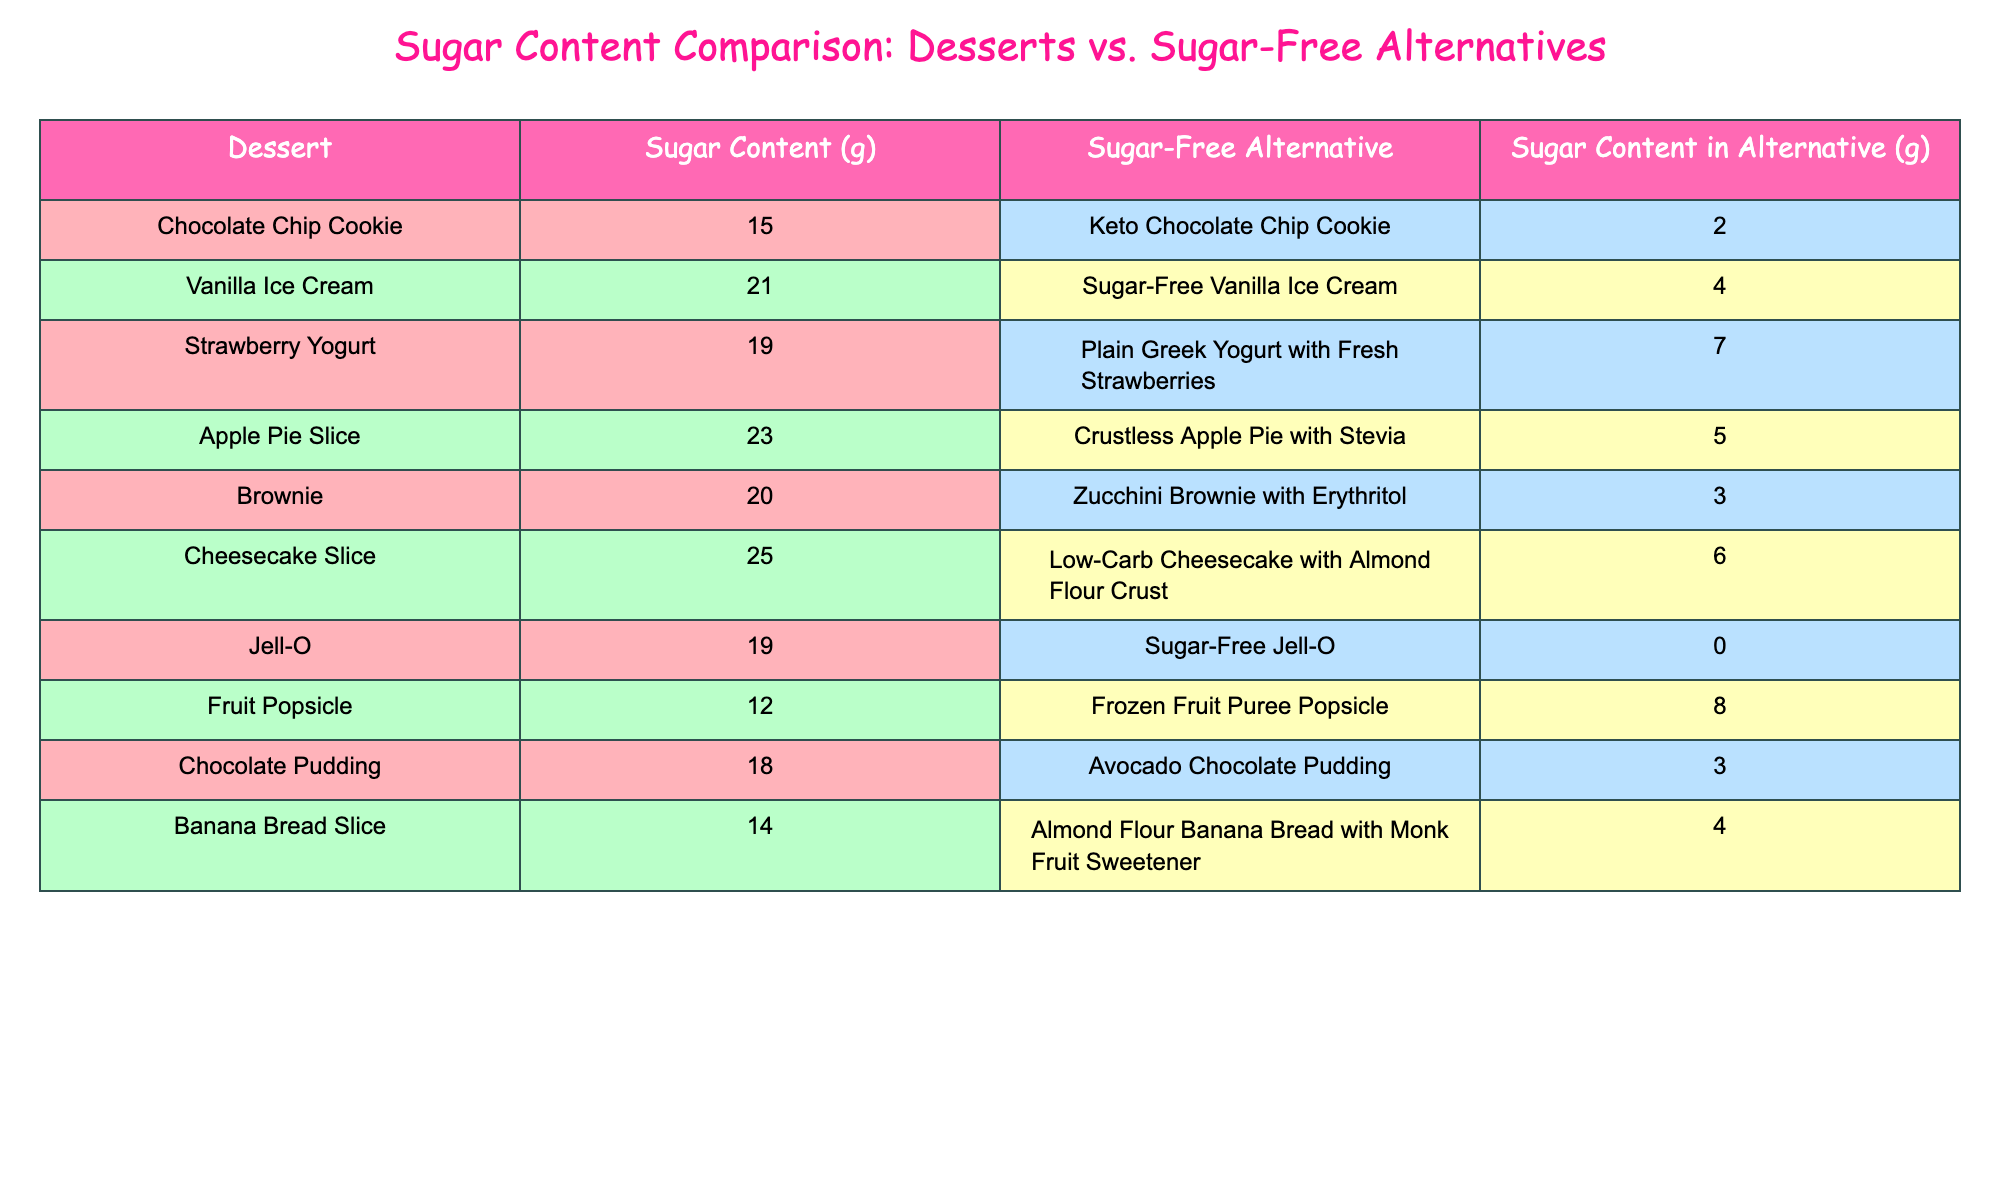What is the sugar content of the Vanilla Ice Cream? The sugar content listed in the table for Vanilla Ice Cream is 21 grams. Therefore, the answer is directly found in the specific row corresponding to Vanilla Ice Cream.
Answer: 21 Which dessert has the highest sugar content? By looking at the sugar content column, we find that Cheesecake Slice has the highest sugar content at 25 grams. This is determined simply by comparing the values.
Answer: 25 What is the total sugar content of Chocolate Chip Cookies and Brownies? The two desserts total sugar content is calculated by adding the sugar content of Chocolate Chip Cookie (15 grams) and Brownie (20 grams): 15 + 20 = 35 grams. This requires summing the values of the two desserts.
Answer: 35 Is the sugar content of Jell-O higher than that of Frozen Fruit Puree Popsicle? Jell-O has a sugar content of 19 grams, while Frozen Fruit Puree Popsicle has 8 grams. Since 19 is greater than 8, the answer is yes. This is a straightforward comparison of two values.
Answer: Yes What is the difference in sugar content between Crustless Apple Pie with Stevia and Low-Carb Cheesecake with Almond Flour Crust? Crustless Apple Pie with Stevia contains 5 grams of sugar and Low-Carb Cheesecake with Almond Flour Crust contains 6 grams. The difference is calculated as 6 - 5 = 1 gram. This requires a subtraction of the two values.
Answer: 1 Which has less sugar content: the Keto Chocolate Chip Cookie or the Zucchini Brownie with Erythritol? The sugar content for the Keto Chocolate Chip Cookie is 2 grams, while the Zucchini Brownie has 3 grams. Since 2 is less than 3, the answer is that Keto Chocolate Chip Cookie has less sugar. This involves a direct comparison of two values.
Answer: Keto Chocolate Chip Cookie What is the average sugar content for the sugar-free alternatives listed? First, we find the total sugar content of the sugar-free alternatives: 2 + 4 + 7 + 5 + 3 + 6 + 0 + 8 + 3 + 4 = 38 grams. Then, since there are 10 alternatives, we divide the total by 10 to find the average: 38 / 10 = 3.8 grams. This requires summing all the sugar content values and then dividing by the number of alternatives.
Answer: 3.8 Which dessert's sugar content reduces the most when switching to its sugar-free alternative? By comparing the sugar content of each dessert with its alternative, we find the greatest reduction: Cheesecake decreases from 25 to 6 (19 grams reduced), while Brownie decreases from 20 to 3 (17 grams reduced). The largest decrease is 19 grams for Cheesecake. This involves checking the differences for all desserts and finding the maximum.
Answer: 19 How many desserts have a sugar content of 20 grams or more? The desserts with 20 grams or more are the Cheesecake Slice (25g), Brownie (20g), and Apple Pie Slice (23g). So there are 3 desserts that meet the criteria. This requires counting the number of desserts that fit the specified condition.
Answer: 3 